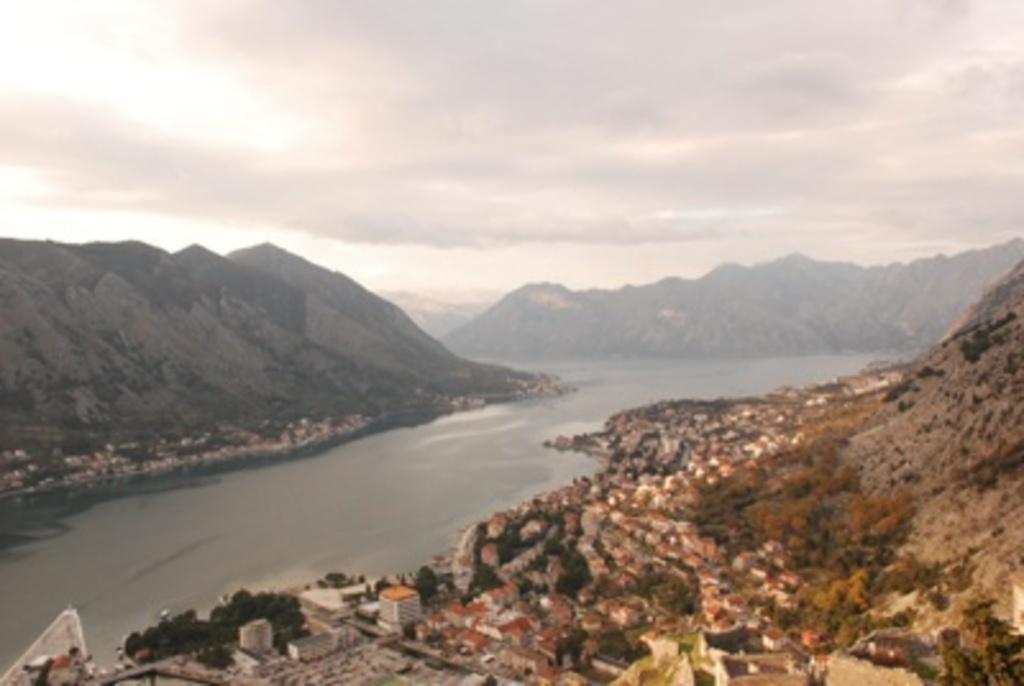What natural feature is the main subject of the image? There is a river in the image. What can be seen on the sides of the river? There are trees and buildings on the sides of the river. What type of geographical feature is visible in the image? There are hills in the image. What is visible in the background of the image? The sky is visible in the background of the image. What type of baseball can be seen in the image? There is no baseball present in the image. What is the turkey doing in the image? There is no turkey present in the image. 